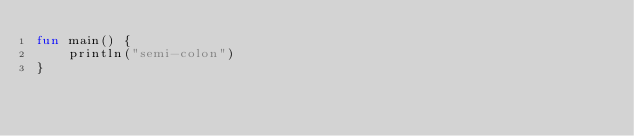Convert code to text. <code><loc_0><loc_0><loc_500><loc_500><_Kotlin_>fun main() {
    println("semi-colon")
}
</code> 